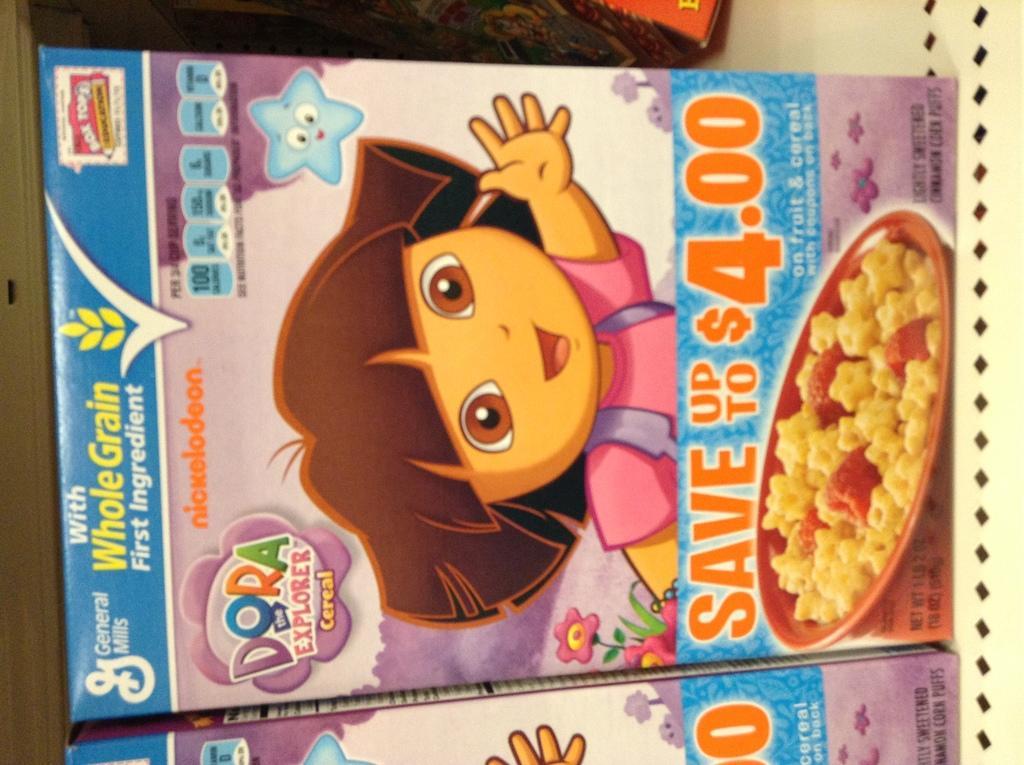Please provide a concise description of this image. In the image there are two cereal boxes beside each other with graphic images on it, this is a vertical image. 